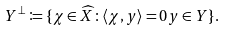<formula> <loc_0><loc_0><loc_500><loc_500>Y ^ { \perp } \coloneqq \{ \chi \in \widehat { X } \colon \langle \chi , y \rangle = 0 y \in Y \} .</formula> 